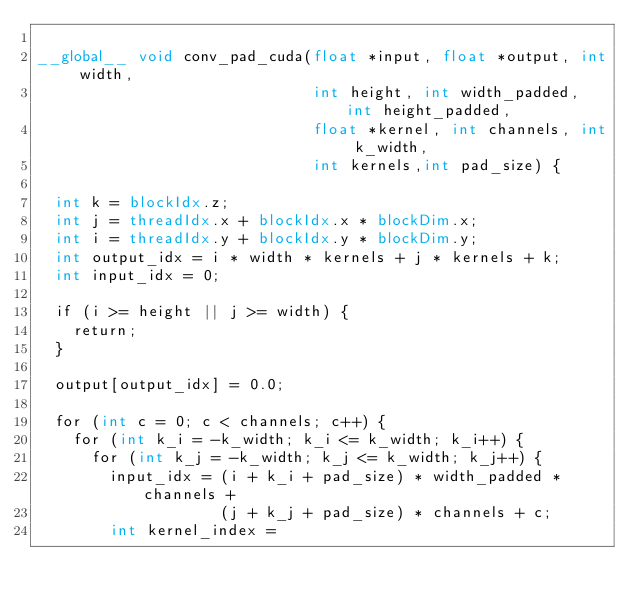Convert code to text. <code><loc_0><loc_0><loc_500><loc_500><_Cuda_>
__global__ void conv_pad_cuda(float *input, float *output, int width,
                              int height, int width_padded, int height_padded,
                              float *kernel, int channels, int k_width,
                              int kernels,int pad_size) {

  int k = blockIdx.z;
  int j = threadIdx.x + blockIdx.x * blockDim.x;
  int i = threadIdx.y + blockIdx.y * blockDim.y;
  int output_idx = i * width * kernels + j * kernels + k;
  int input_idx = 0;

  if (i >= height || j >= width) {
    return;
  }

  output[output_idx] = 0.0;

  for (int c = 0; c < channels; c++) {
    for (int k_i = -k_width; k_i <= k_width; k_i++) {
      for (int k_j = -k_width; k_j <= k_width; k_j++) {
        input_idx = (i + k_i + pad_size) * width_padded * channels +
                    (j + k_j + pad_size) * channels + c;
        int kernel_index =</code> 